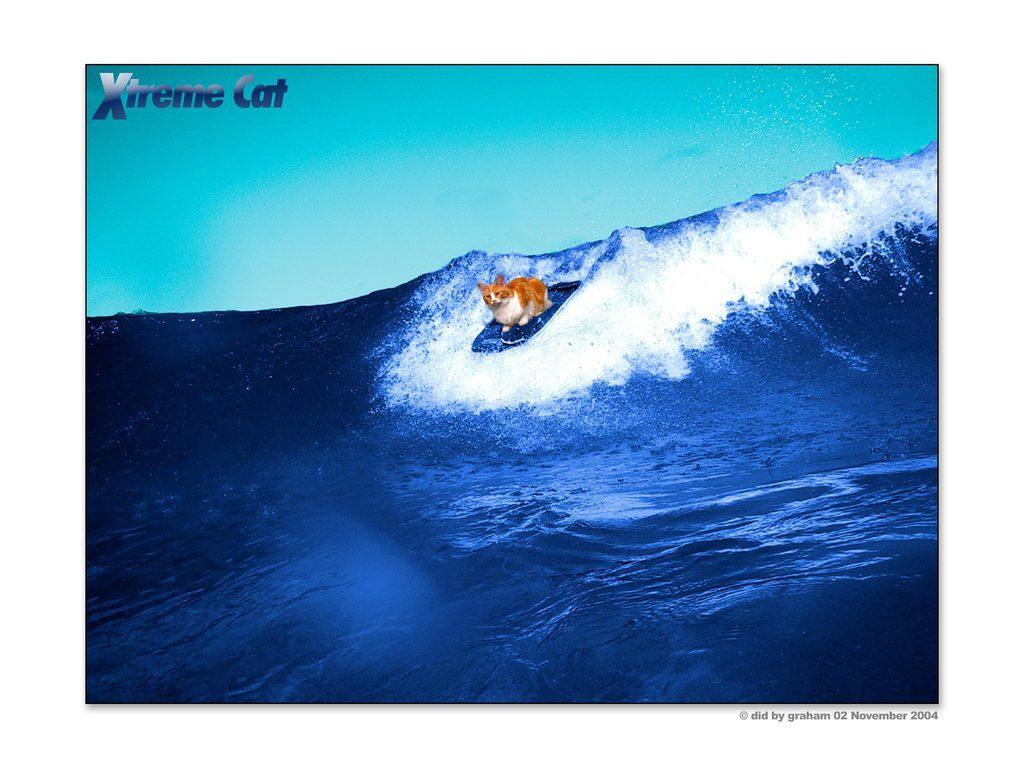How would you summarize this image in a sentence or two? In this image there is a cat which is surfing in the water by sitting on the surf board. 